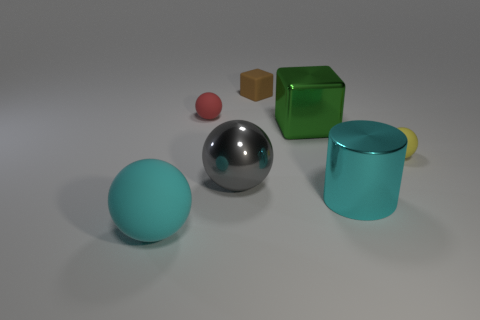Subtract all rubber balls. How many balls are left? 1 Add 3 brown cylinders. How many objects exist? 10 Subtract all gray spheres. How many spheres are left? 3 Subtract all spheres. How many objects are left? 3 Subtract 0 yellow cubes. How many objects are left? 7 Subtract all brown cylinders. Subtract all brown spheres. How many cylinders are left? 1 Subtract all big cyan rubber objects. Subtract all green metal blocks. How many objects are left? 5 Add 4 big cyan spheres. How many big cyan spheres are left? 5 Add 4 small yellow rubber spheres. How many small yellow rubber spheres exist? 5 